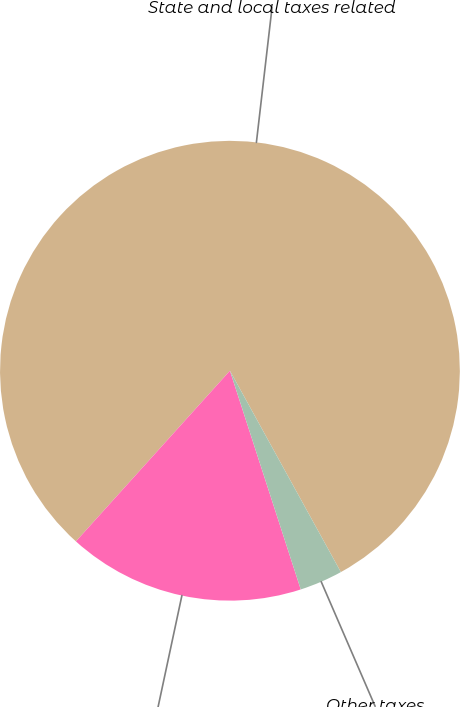<chart> <loc_0><loc_0><loc_500><loc_500><pie_chart><fcel>State and local taxes related<fcel>Payroll taxes<fcel>Other taxes<nl><fcel>80.3%<fcel>16.67%<fcel>3.03%<nl></chart> 